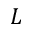<formula> <loc_0><loc_0><loc_500><loc_500>L</formula> 